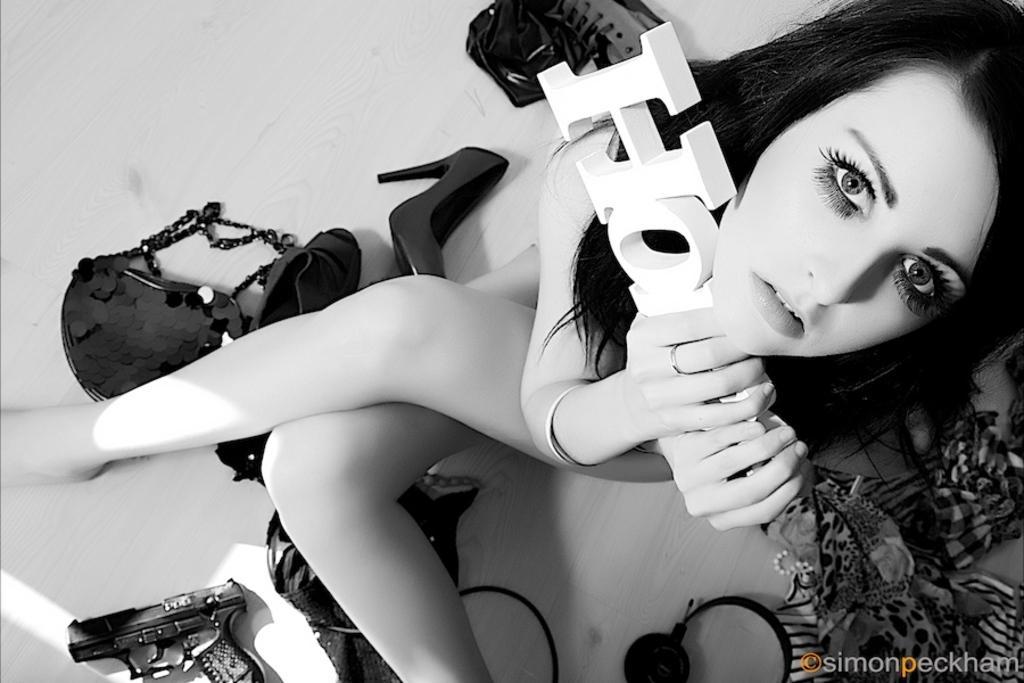In one or two sentences, can you explain what this image depicts? In the picture we can see a woman holding something in her hands and there are some other things on floor like bag, shoes, gun, headphones. 